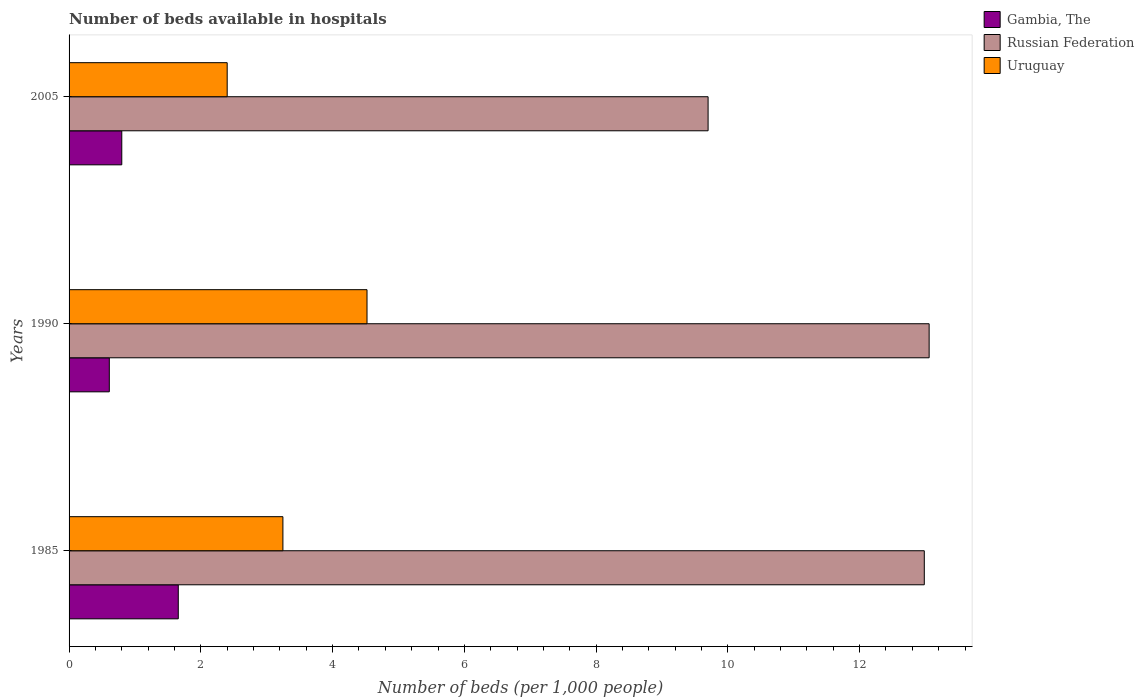How many different coloured bars are there?
Your response must be concise. 3. How many bars are there on the 1st tick from the top?
Your answer should be compact. 3. How many bars are there on the 1st tick from the bottom?
Keep it short and to the point. 3. What is the label of the 3rd group of bars from the top?
Give a very brief answer. 1985. In how many cases, is the number of bars for a given year not equal to the number of legend labels?
Make the answer very short. 0. What is the number of beds in the hospiatls of in Russian Federation in 2005?
Your response must be concise. 9.7. Across all years, what is the maximum number of beds in the hospiatls of in Russian Federation?
Give a very brief answer. 13.06. In which year was the number of beds in the hospiatls of in Uruguay minimum?
Your answer should be very brief. 2005. What is the total number of beds in the hospiatls of in Uruguay in the graph?
Offer a very short reply. 10.17. What is the difference between the number of beds in the hospiatls of in Gambia, The in 1985 and that in 2005?
Your response must be concise. 0.86. What is the difference between the number of beds in the hospiatls of in Uruguay in 2005 and the number of beds in the hospiatls of in Gambia, The in 1985?
Give a very brief answer. 0.74. What is the average number of beds in the hospiatls of in Russian Federation per year?
Make the answer very short. 11.91. In the year 1990, what is the difference between the number of beds in the hospiatls of in Gambia, The and number of beds in the hospiatls of in Russian Federation?
Your answer should be compact. -12.44. What is the ratio of the number of beds in the hospiatls of in Russian Federation in 1990 to that in 2005?
Give a very brief answer. 1.35. Is the number of beds in the hospiatls of in Gambia, The in 1985 less than that in 1990?
Offer a terse response. No. What is the difference between the highest and the second highest number of beds in the hospiatls of in Uruguay?
Provide a succinct answer. 1.28. What is the difference between the highest and the lowest number of beds in the hospiatls of in Gambia, The?
Ensure brevity in your answer.  1.05. What does the 3rd bar from the top in 1990 represents?
Keep it short and to the point. Gambia, The. What does the 1st bar from the bottom in 1985 represents?
Keep it short and to the point. Gambia, The. Is it the case that in every year, the sum of the number of beds in the hospiatls of in Gambia, The and number of beds in the hospiatls of in Uruguay is greater than the number of beds in the hospiatls of in Russian Federation?
Offer a very short reply. No. Are the values on the major ticks of X-axis written in scientific E-notation?
Ensure brevity in your answer.  No. Where does the legend appear in the graph?
Your answer should be compact. Top right. What is the title of the graph?
Offer a very short reply. Number of beds available in hospitals. Does "Korea (Republic)" appear as one of the legend labels in the graph?
Your response must be concise. No. What is the label or title of the X-axis?
Ensure brevity in your answer.  Number of beds (per 1,0 people). What is the Number of beds (per 1,000 people) of Gambia, The in 1985?
Ensure brevity in your answer.  1.66. What is the Number of beds (per 1,000 people) of Russian Federation in 1985?
Give a very brief answer. 12.98. What is the Number of beds (per 1,000 people) in Uruguay in 1985?
Ensure brevity in your answer.  3.25. What is the Number of beds (per 1,000 people) in Gambia, The in 1990?
Make the answer very short. 0.61. What is the Number of beds (per 1,000 people) of Russian Federation in 1990?
Your response must be concise. 13.06. What is the Number of beds (per 1,000 people) of Uruguay in 1990?
Offer a terse response. 4.52. What is the Number of beds (per 1,000 people) of Gambia, The in 2005?
Make the answer very short. 0.8. What is the Number of beds (per 1,000 people) of Russian Federation in 2005?
Your answer should be very brief. 9.7. What is the Number of beds (per 1,000 people) of Uruguay in 2005?
Provide a short and direct response. 2.4. Across all years, what is the maximum Number of beds (per 1,000 people) in Gambia, The?
Offer a terse response. 1.66. Across all years, what is the maximum Number of beds (per 1,000 people) of Russian Federation?
Keep it short and to the point. 13.06. Across all years, what is the maximum Number of beds (per 1,000 people) in Uruguay?
Provide a succinct answer. 4.52. Across all years, what is the minimum Number of beds (per 1,000 people) in Gambia, The?
Provide a short and direct response. 0.61. Across all years, what is the minimum Number of beds (per 1,000 people) in Russian Federation?
Your answer should be very brief. 9.7. Across all years, what is the minimum Number of beds (per 1,000 people) of Uruguay?
Make the answer very short. 2.4. What is the total Number of beds (per 1,000 people) of Gambia, The in the graph?
Provide a short and direct response. 3.07. What is the total Number of beds (per 1,000 people) of Russian Federation in the graph?
Keep it short and to the point. 35.74. What is the total Number of beds (per 1,000 people) in Uruguay in the graph?
Give a very brief answer. 10.17. What is the difference between the Number of beds (per 1,000 people) in Gambia, The in 1985 and that in 1990?
Offer a terse response. 1.05. What is the difference between the Number of beds (per 1,000 people) of Russian Federation in 1985 and that in 1990?
Provide a short and direct response. -0.07. What is the difference between the Number of beds (per 1,000 people) in Uruguay in 1985 and that in 1990?
Your response must be concise. -1.28. What is the difference between the Number of beds (per 1,000 people) in Gambia, The in 1985 and that in 2005?
Your answer should be very brief. 0.86. What is the difference between the Number of beds (per 1,000 people) in Russian Federation in 1985 and that in 2005?
Offer a very short reply. 3.28. What is the difference between the Number of beds (per 1,000 people) of Uruguay in 1985 and that in 2005?
Provide a succinct answer. 0.85. What is the difference between the Number of beds (per 1,000 people) in Gambia, The in 1990 and that in 2005?
Your answer should be compact. -0.19. What is the difference between the Number of beds (per 1,000 people) of Russian Federation in 1990 and that in 2005?
Make the answer very short. 3.36. What is the difference between the Number of beds (per 1,000 people) of Uruguay in 1990 and that in 2005?
Give a very brief answer. 2.12. What is the difference between the Number of beds (per 1,000 people) of Gambia, The in 1985 and the Number of beds (per 1,000 people) of Russian Federation in 1990?
Your response must be concise. -11.4. What is the difference between the Number of beds (per 1,000 people) of Gambia, The in 1985 and the Number of beds (per 1,000 people) of Uruguay in 1990?
Make the answer very short. -2.86. What is the difference between the Number of beds (per 1,000 people) of Russian Federation in 1985 and the Number of beds (per 1,000 people) of Uruguay in 1990?
Ensure brevity in your answer.  8.46. What is the difference between the Number of beds (per 1,000 people) of Gambia, The in 1985 and the Number of beds (per 1,000 people) of Russian Federation in 2005?
Give a very brief answer. -8.04. What is the difference between the Number of beds (per 1,000 people) of Gambia, The in 1985 and the Number of beds (per 1,000 people) of Uruguay in 2005?
Provide a succinct answer. -0.74. What is the difference between the Number of beds (per 1,000 people) in Russian Federation in 1985 and the Number of beds (per 1,000 people) in Uruguay in 2005?
Provide a short and direct response. 10.58. What is the difference between the Number of beds (per 1,000 people) of Gambia, The in 1990 and the Number of beds (per 1,000 people) of Russian Federation in 2005?
Offer a very short reply. -9.09. What is the difference between the Number of beds (per 1,000 people) of Gambia, The in 1990 and the Number of beds (per 1,000 people) of Uruguay in 2005?
Offer a very short reply. -1.79. What is the difference between the Number of beds (per 1,000 people) in Russian Federation in 1990 and the Number of beds (per 1,000 people) in Uruguay in 2005?
Give a very brief answer. 10.66. What is the average Number of beds (per 1,000 people) in Gambia, The per year?
Your answer should be very brief. 1.02. What is the average Number of beds (per 1,000 people) in Russian Federation per year?
Provide a short and direct response. 11.91. What is the average Number of beds (per 1,000 people) of Uruguay per year?
Offer a terse response. 3.39. In the year 1985, what is the difference between the Number of beds (per 1,000 people) of Gambia, The and Number of beds (per 1,000 people) of Russian Federation?
Your answer should be compact. -11.32. In the year 1985, what is the difference between the Number of beds (per 1,000 people) of Gambia, The and Number of beds (per 1,000 people) of Uruguay?
Your response must be concise. -1.59. In the year 1985, what is the difference between the Number of beds (per 1,000 people) of Russian Federation and Number of beds (per 1,000 people) of Uruguay?
Your answer should be very brief. 9.74. In the year 1990, what is the difference between the Number of beds (per 1,000 people) in Gambia, The and Number of beds (per 1,000 people) in Russian Federation?
Your answer should be very brief. -12.44. In the year 1990, what is the difference between the Number of beds (per 1,000 people) in Gambia, The and Number of beds (per 1,000 people) in Uruguay?
Keep it short and to the point. -3.91. In the year 1990, what is the difference between the Number of beds (per 1,000 people) in Russian Federation and Number of beds (per 1,000 people) in Uruguay?
Provide a short and direct response. 8.53. What is the ratio of the Number of beds (per 1,000 people) in Gambia, The in 1985 to that in 1990?
Make the answer very short. 2.71. What is the ratio of the Number of beds (per 1,000 people) in Russian Federation in 1985 to that in 1990?
Your response must be concise. 0.99. What is the ratio of the Number of beds (per 1,000 people) in Uruguay in 1985 to that in 1990?
Offer a very short reply. 0.72. What is the ratio of the Number of beds (per 1,000 people) of Gambia, The in 1985 to that in 2005?
Give a very brief answer. 2.07. What is the ratio of the Number of beds (per 1,000 people) in Russian Federation in 1985 to that in 2005?
Provide a short and direct response. 1.34. What is the ratio of the Number of beds (per 1,000 people) in Uruguay in 1985 to that in 2005?
Offer a terse response. 1.35. What is the ratio of the Number of beds (per 1,000 people) of Gambia, The in 1990 to that in 2005?
Your answer should be compact. 0.76. What is the ratio of the Number of beds (per 1,000 people) of Russian Federation in 1990 to that in 2005?
Ensure brevity in your answer.  1.35. What is the ratio of the Number of beds (per 1,000 people) of Uruguay in 1990 to that in 2005?
Provide a short and direct response. 1.88. What is the difference between the highest and the second highest Number of beds (per 1,000 people) in Gambia, The?
Offer a terse response. 0.86. What is the difference between the highest and the second highest Number of beds (per 1,000 people) in Russian Federation?
Make the answer very short. 0.07. What is the difference between the highest and the second highest Number of beds (per 1,000 people) of Uruguay?
Your answer should be compact. 1.28. What is the difference between the highest and the lowest Number of beds (per 1,000 people) in Gambia, The?
Provide a succinct answer. 1.05. What is the difference between the highest and the lowest Number of beds (per 1,000 people) in Russian Federation?
Give a very brief answer. 3.36. What is the difference between the highest and the lowest Number of beds (per 1,000 people) in Uruguay?
Make the answer very short. 2.12. 